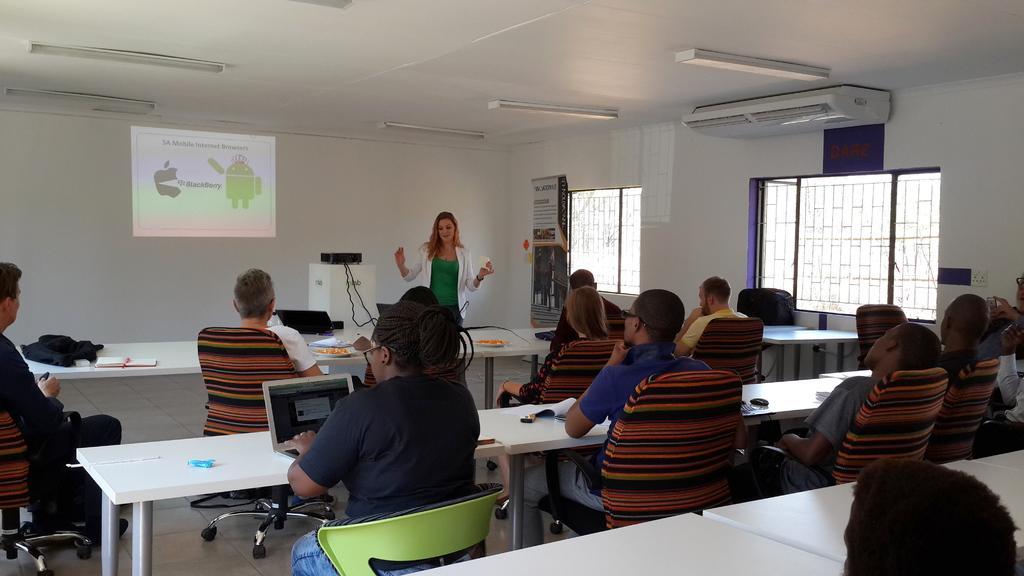Could you give a brief overview of what you see in this image? In this image there are group of people sitting in chair near the table in the back ground there is hoarding , air conditioner , light, screen , projector,woman. 